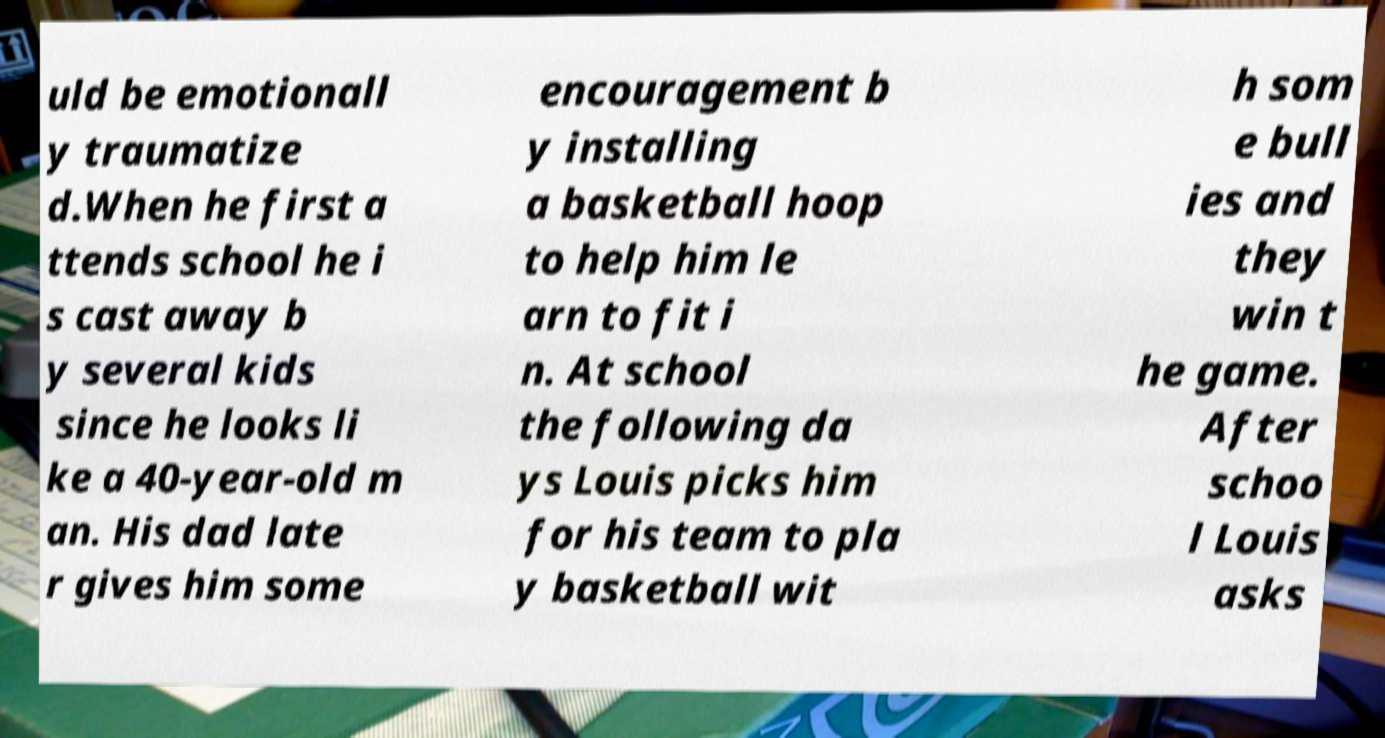I need the written content from this picture converted into text. Can you do that? uld be emotionall y traumatize d.When he first a ttends school he i s cast away b y several kids since he looks li ke a 40-year-old m an. His dad late r gives him some encouragement b y installing a basketball hoop to help him le arn to fit i n. At school the following da ys Louis picks him for his team to pla y basketball wit h som e bull ies and they win t he game. After schoo l Louis asks 